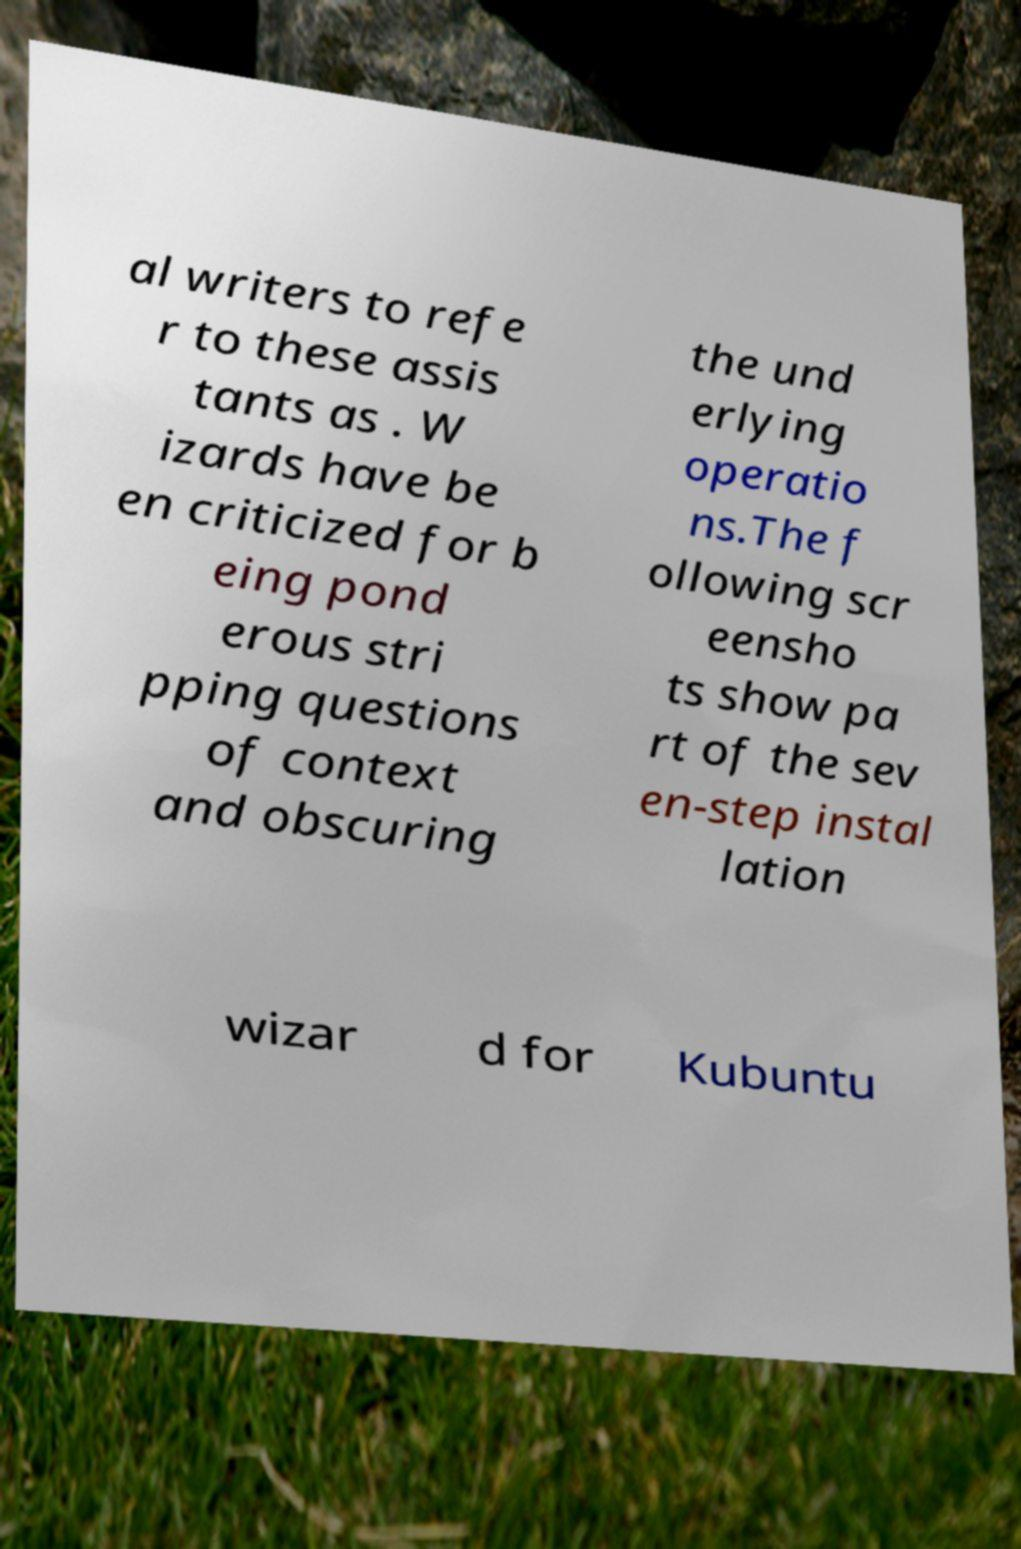Could you extract and type out the text from this image? al writers to refe r to these assis tants as . W izards have be en criticized for b eing pond erous stri pping questions of context and obscuring the und erlying operatio ns.The f ollowing scr eensho ts show pa rt of the sev en-step instal lation wizar d for Kubuntu 